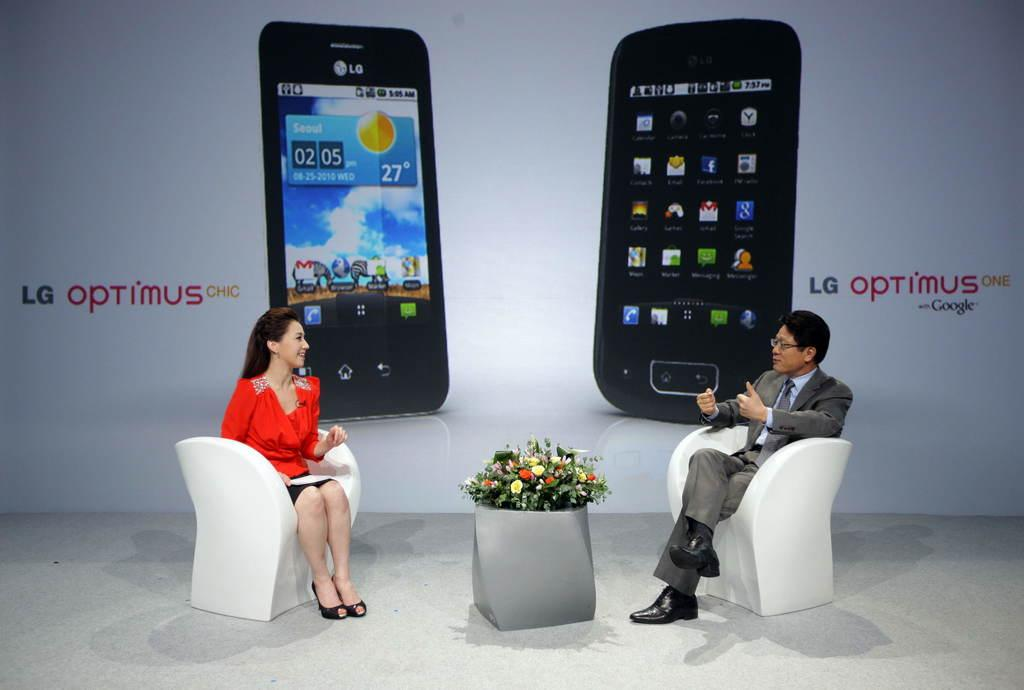<image>
Relay a brief, clear account of the picture shown. a meeting between two people regarding the LG optimus 